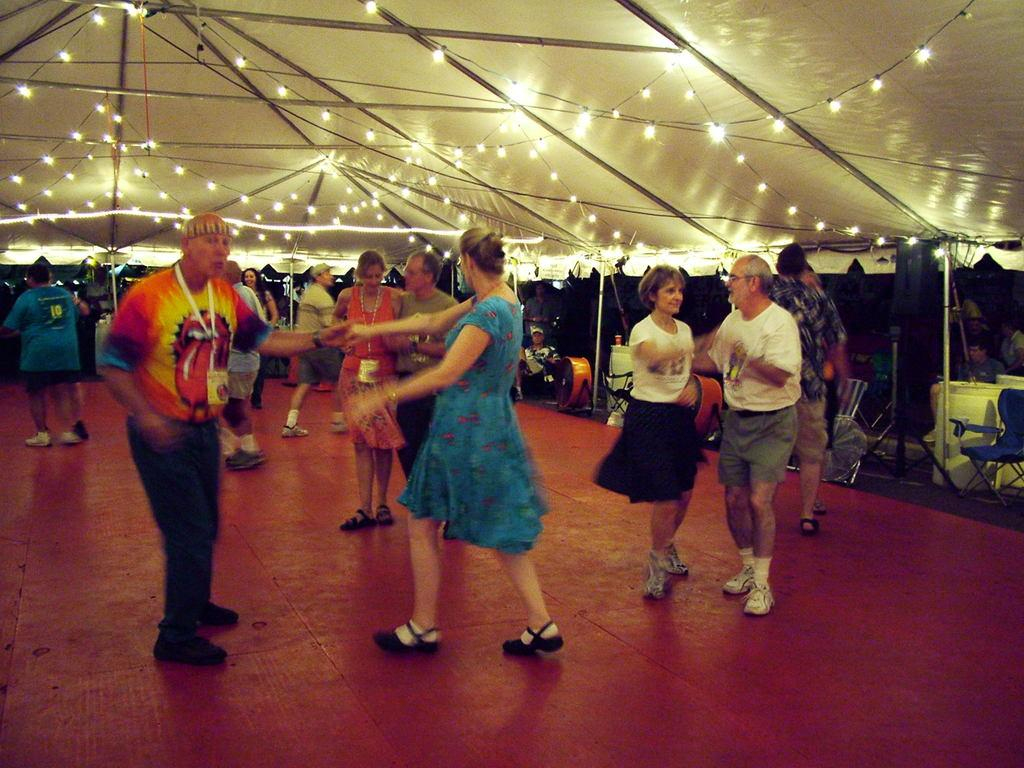What are the people in the image doing? The people in the image are dancing on a stage. What is above the stage in the image? There is a tent above the stage. How is the stage illuminated in the image? The stage has beautiful lighting. Who is watching the people dancing on the stage? There is an audience watching the dance. What type of chicken is being played by the band in the image? There is no band or chicken present in the image; it features people dancing on a stage with a tent above it and an audience watching. 